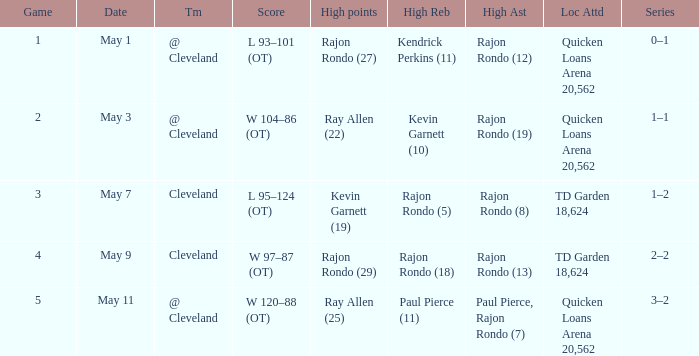Where does the team play May 3? @ Cleveland. 